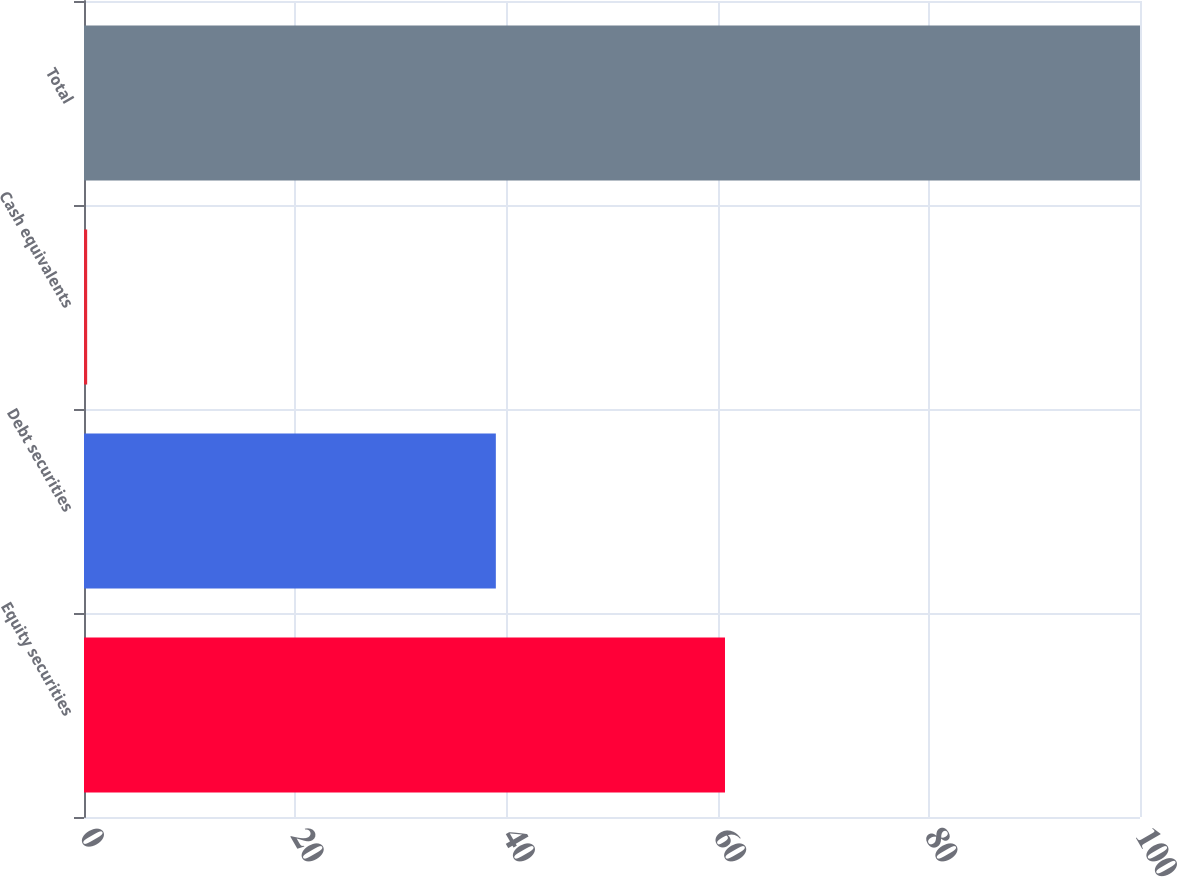<chart> <loc_0><loc_0><loc_500><loc_500><bar_chart><fcel>Equity securities<fcel>Debt securities<fcel>Cash equivalents<fcel>Total<nl><fcel>60.7<fcel>39<fcel>0.3<fcel>100<nl></chart> 